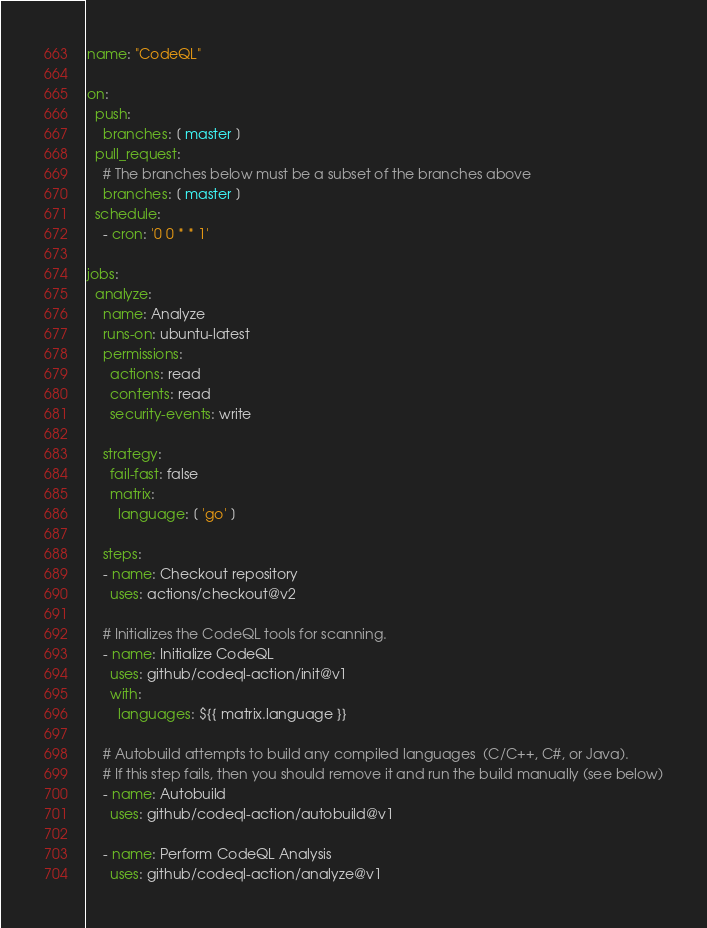<code> <loc_0><loc_0><loc_500><loc_500><_YAML_>name: "CodeQL"

on:
  push:
    branches: [ master ]
  pull_request:
    # The branches below must be a subset of the branches above
    branches: [ master ]
  schedule:
    - cron: '0 0 * * 1'

jobs:
  analyze:
    name: Analyze
    runs-on: ubuntu-latest
    permissions:
      actions: read
      contents: read
      security-events: write

    strategy:
      fail-fast: false
      matrix:
        language: [ 'go' ]
        
    steps:
    - name: Checkout repository
      uses: actions/checkout@v2

    # Initializes the CodeQL tools for scanning.
    - name: Initialize CodeQL
      uses: github/codeql-action/init@v1
      with:
        languages: ${{ matrix.language }}

    # Autobuild attempts to build any compiled languages  (C/C++, C#, or Java).
    # If this step fails, then you should remove it and run the build manually (see below)
    - name: Autobuild
      uses: github/codeql-action/autobuild@v1

    - name: Perform CodeQL Analysis
      uses: github/codeql-action/analyze@v1
</code> 